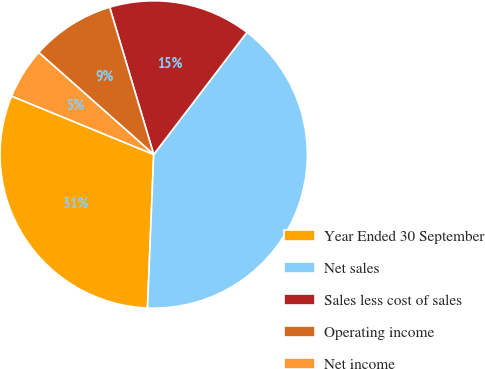<chart> <loc_0><loc_0><loc_500><loc_500><pie_chart><fcel>Year Ended 30 September<fcel>Net sales<fcel>Sales less cost of sales<fcel>Operating income<fcel>Net income<nl><fcel>30.56%<fcel>40.27%<fcel>15.0%<fcel>8.83%<fcel>5.34%<nl></chart> 